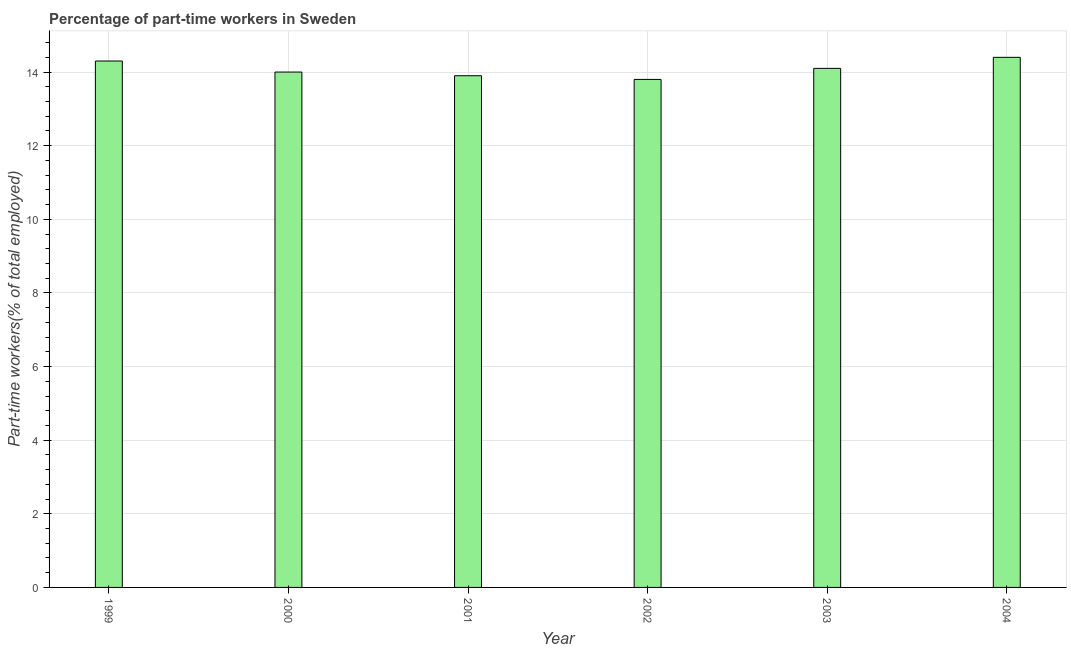Does the graph contain any zero values?
Ensure brevity in your answer.  No. What is the title of the graph?
Offer a very short reply. Percentage of part-time workers in Sweden. What is the label or title of the X-axis?
Provide a short and direct response. Year. What is the label or title of the Y-axis?
Your answer should be very brief. Part-time workers(% of total employed). What is the percentage of part-time workers in 1999?
Provide a short and direct response. 14.3. Across all years, what is the maximum percentage of part-time workers?
Keep it short and to the point. 14.4. Across all years, what is the minimum percentage of part-time workers?
Your response must be concise. 13.8. In which year was the percentage of part-time workers maximum?
Ensure brevity in your answer.  2004. What is the sum of the percentage of part-time workers?
Keep it short and to the point. 84.5. What is the difference between the percentage of part-time workers in 2002 and 2003?
Offer a very short reply. -0.3. What is the average percentage of part-time workers per year?
Give a very brief answer. 14.08. What is the median percentage of part-time workers?
Provide a short and direct response. 14.05. In how many years, is the percentage of part-time workers greater than 11.2 %?
Ensure brevity in your answer.  6. What is the ratio of the percentage of part-time workers in 2001 to that in 2003?
Ensure brevity in your answer.  0.99. Is the difference between the percentage of part-time workers in 2002 and 2004 greater than the difference between any two years?
Offer a terse response. Yes. What is the difference between the highest and the second highest percentage of part-time workers?
Provide a succinct answer. 0.1. Is the sum of the percentage of part-time workers in 2002 and 2004 greater than the maximum percentage of part-time workers across all years?
Make the answer very short. Yes. Are all the bars in the graph horizontal?
Offer a very short reply. No. Are the values on the major ticks of Y-axis written in scientific E-notation?
Offer a very short reply. No. What is the Part-time workers(% of total employed) in 1999?
Your answer should be compact. 14.3. What is the Part-time workers(% of total employed) in 2000?
Keep it short and to the point. 14. What is the Part-time workers(% of total employed) of 2001?
Provide a succinct answer. 13.9. What is the Part-time workers(% of total employed) in 2002?
Provide a short and direct response. 13.8. What is the Part-time workers(% of total employed) of 2003?
Make the answer very short. 14.1. What is the Part-time workers(% of total employed) in 2004?
Provide a succinct answer. 14.4. What is the difference between the Part-time workers(% of total employed) in 1999 and 2000?
Make the answer very short. 0.3. What is the difference between the Part-time workers(% of total employed) in 1999 and 2001?
Offer a very short reply. 0.4. What is the difference between the Part-time workers(% of total employed) in 2000 and 2001?
Offer a very short reply. 0.1. What is the difference between the Part-time workers(% of total employed) in 2000 and 2002?
Offer a terse response. 0.2. What is the difference between the Part-time workers(% of total employed) in 2002 and 2004?
Offer a terse response. -0.6. What is the difference between the Part-time workers(% of total employed) in 2003 and 2004?
Ensure brevity in your answer.  -0.3. What is the ratio of the Part-time workers(% of total employed) in 1999 to that in 2001?
Ensure brevity in your answer.  1.03. What is the ratio of the Part-time workers(% of total employed) in 1999 to that in 2002?
Your answer should be very brief. 1.04. What is the ratio of the Part-time workers(% of total employed) in 2000 to that in 2001?
Provide a short and direct response. 1.01. What is the ratio of the Part-time workers(% of total employed) in 2000 to that in 2003?
Make the answer very short. 0.99. What is the ratio of the Part-time workers(% of total employed) in 2001 to that in 2002?
Ensure brevity in your answer.  1.01. What is the ratio of the Part-time workers(% of total employed) in 2002 to that in 2004?
Keep it short and to the point. 0.96. What is the ratio of the Part-time workers(% of total employed) in 2003 to that in 2004?
Keep it short and to the point. 0.98. 